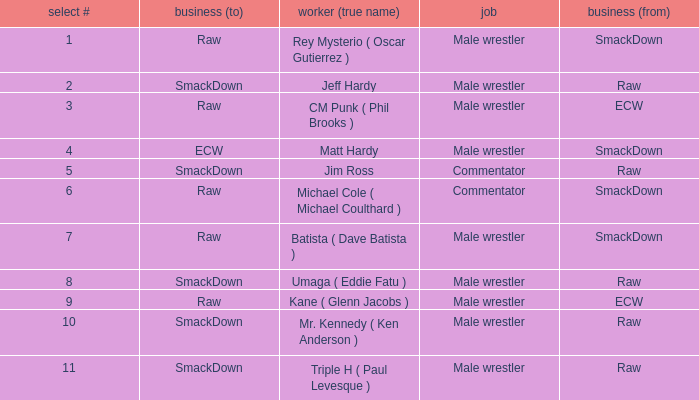What is the real name of the Pick # that is greater than 9? Mr. Kennedy ( Ken Anderson ), Triple H ( Paul Levesque ). 